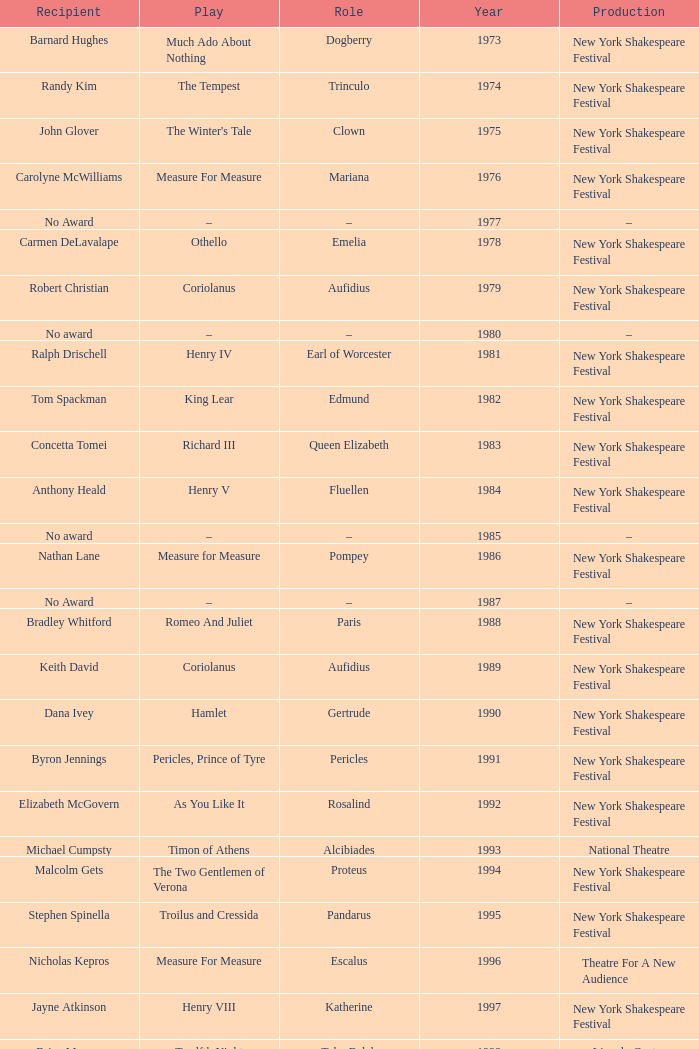Name the average year for much ado about nothing and recipient of ray virta 2002.0. 